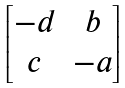Convert formula to latex. <formula><loc_0><loc_0><loc_500><loc_500>\begin{bmatrix} - d & b \\ c & - a \\ \end{bmatrix}</formula> 